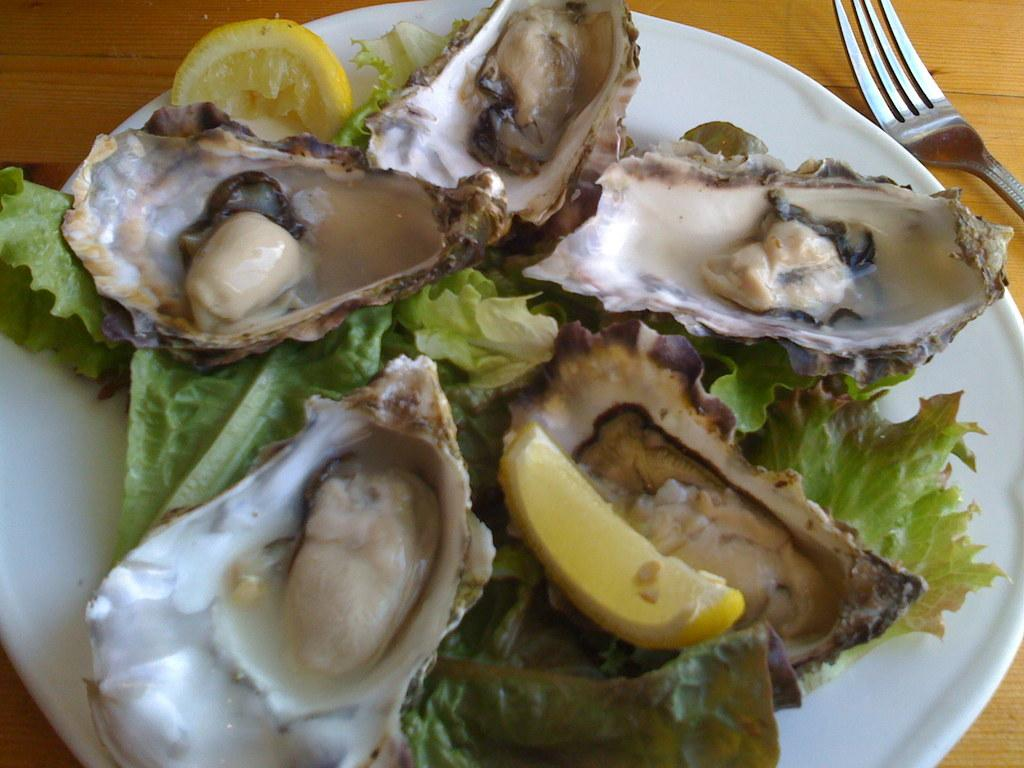What is the main food item visible on the plate in the image? Unfortunately, the specific food item cannot be determined from the provided facts. What utensil is placed beside the plate in the image? There is a fork beside the plate in the image. What type of metal is the reaction fueling in the image? There is no mention of a reaction or fuel in the provided facts, and therefore no such activity can be observed in the image. 